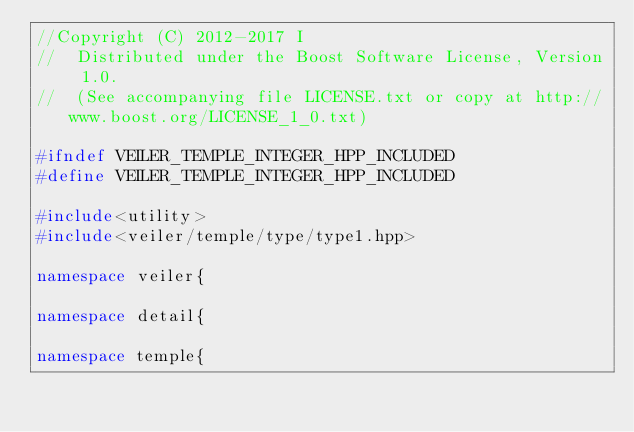Convert code to text. <code><loc_0><loc_0><loc_500><loc_500><_C++_>//Copyright (C) 2012-2017 I
//  Distributed under the Boost Software License, Version 1.0.
//  (See accompanying file LICENSE.txt or copy at http://www.boost.org/LICENSE_1_0.txt)

#ifndef VEILER_TEMPLE_INTEGER_HPP_INCLUDED
#define VEILER_TEMPLE_INTEGER_HPP_INCLUDED

#include<utility>
#include<veiler/temple/type/type1.hpp>

namespace veiler{

namespace detail{

namespace temple{

</code> 